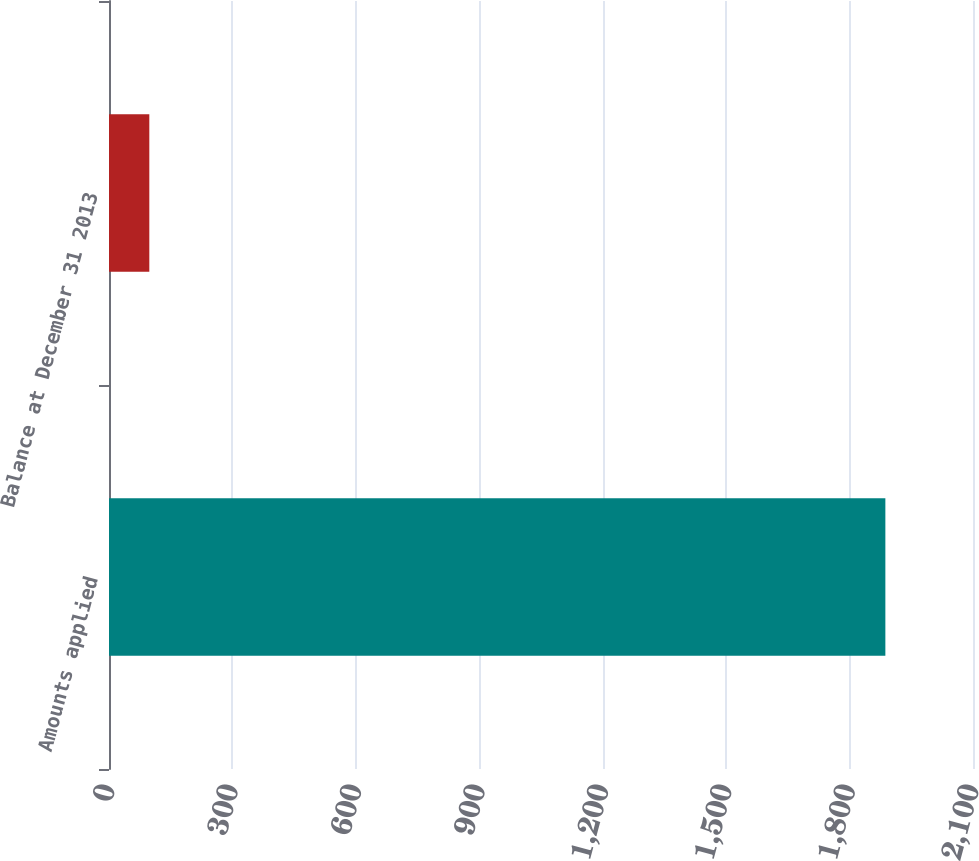Convert chart. <chart><loc_0><loc_0><loc_500><loc_500><bar_chart><fcel>Amounts applied<fcel>Balance at December 31 2013<nl><fcel>1887<fcel>98<nl></chart> 